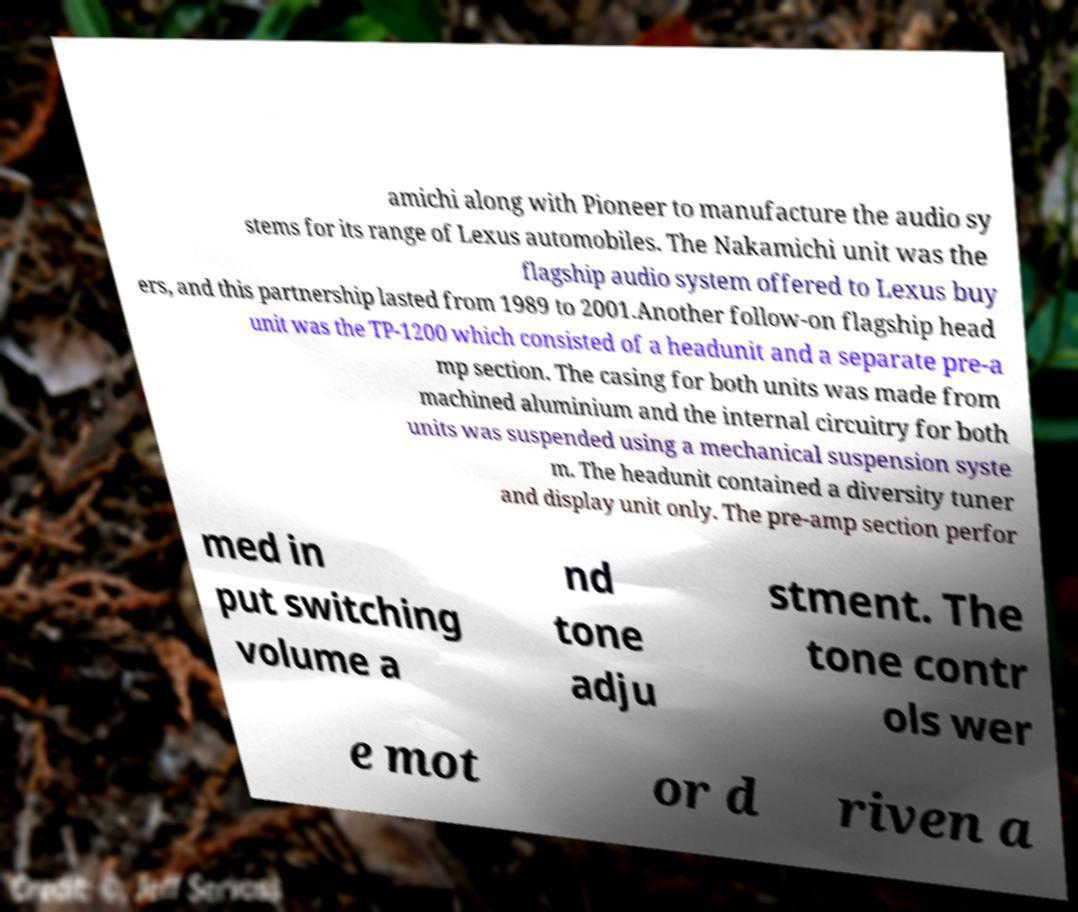There's text embedded in this image that I need extracted. Can you transcribe it verbatim? amichi along with Pioneer to manufacture the audio sy stems for its range of Lexus automobiles. The Nakamichi unit was the flagship audio system offered to Lexus buy ers, and this partnership lasted from 1989 to 2001.Another follow-on flagship head unit was the TP-1200 which consisted of a headunit and a separate pre-a mp section. The casing for both units was made from machined aluminium and the internal circuitry for both units was suspended using a mechanical suspension syste m. The headunit contained a diversity tuner and display unit only. The pre-amp section perfor med in put switching volume a nd tone adju stment. The tone contr ols wer e mot or d riven a 